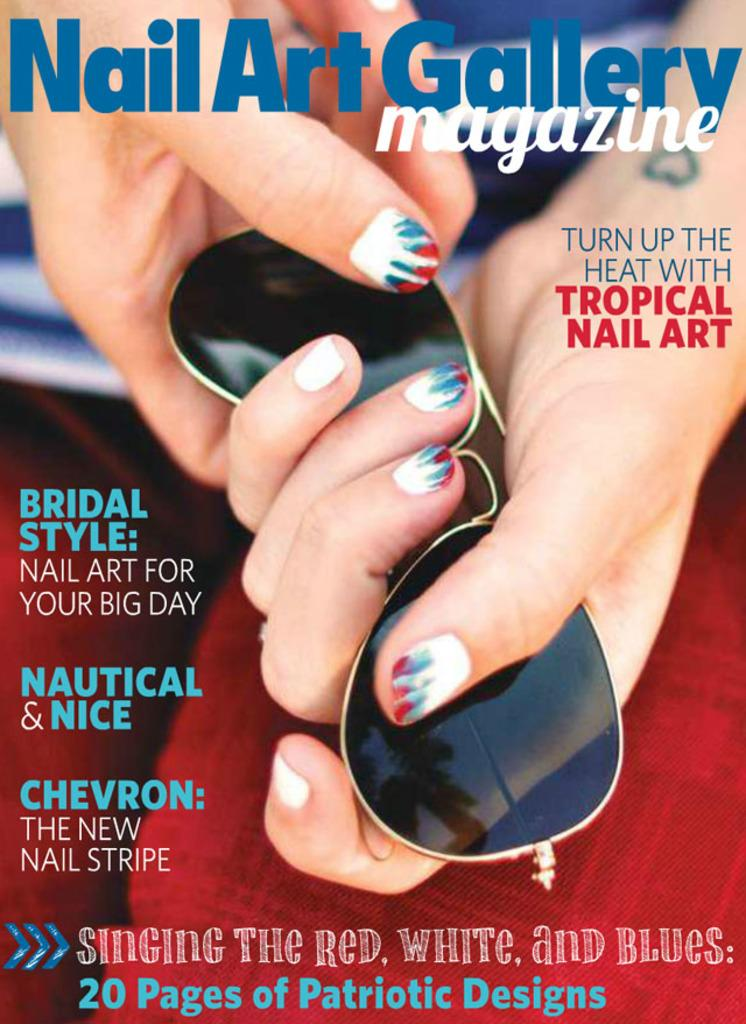<image>
Relay a brief, clear account of the picture shown. A magazine cover of the Nail Art Gallery. 